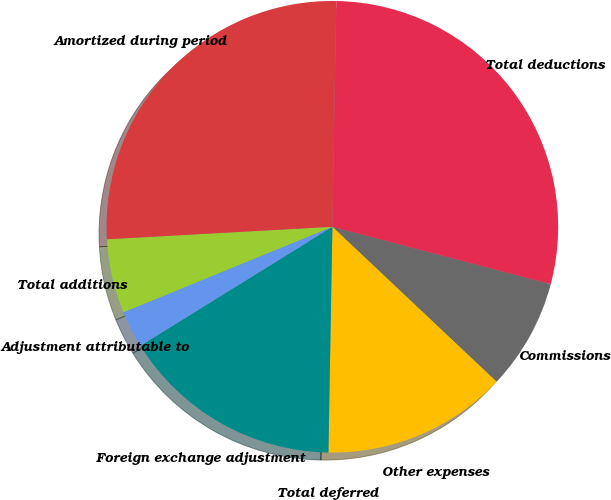Convert chart to OTSL. <chart><loc_0><loc_0><loc_500><loc_500><pie_chart><fcel>Commissions<fcel>Other expenses<fcel>Total deferred<fcel>Foreign exchange adjustment<fcel>Adjustment attributable to<fcel>Total additions<fcel>Amortized during period<fcel>Total deductions<nl><fcel>7.95%<fcel>13.24%<fcel>0.0%<fcel>15.89%<fcel>2.65%<fcel>5.3%<fcel>26.16%<fcel>28.81%<nl></chart> 